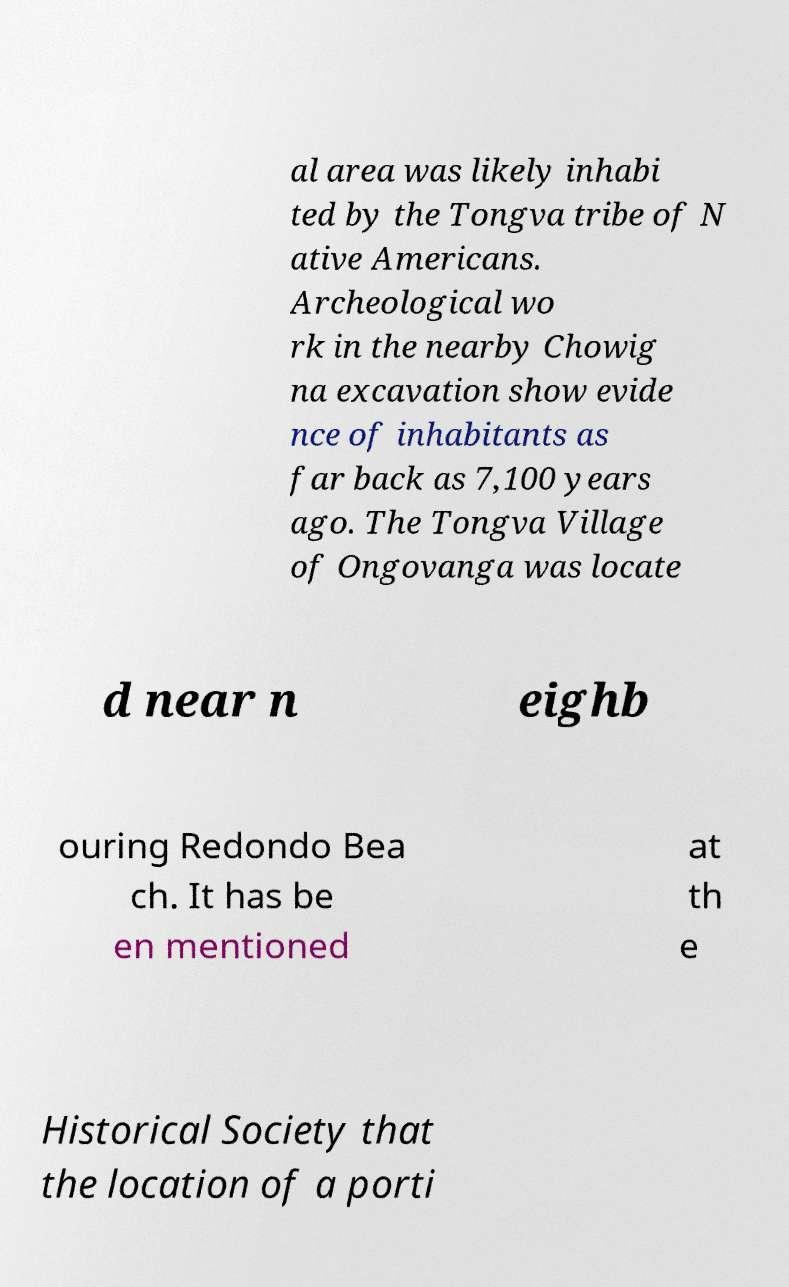I need the written content from this picture converted into text. Can you do that? al area was likely inhabi ted by the Tongva tribe of N ative Americans. Archeological wo rk in the nearby Chowig na excavation show evide nce of inhabitants as far back as 7,100 years ago. The Tongva Village of Ongovanga was locate d near n eighb ouring Redondo Bea ch. It has be en mentioned at th e Historical Society that the location of a porti 